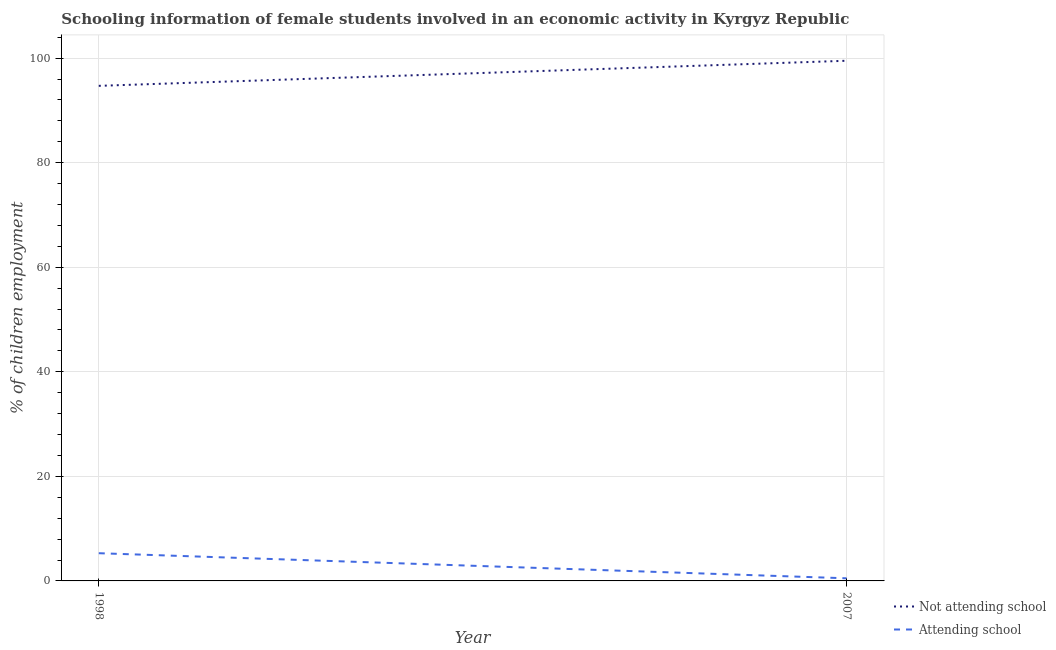Is the number of lines equal to the number of legend labels?
Make the answer very short. Yes. What is the percentage of employed females who are not attending school in 2007?
Provide a succinct answer. 99.5. Across all years, what is the maximum percentage of employed females who are attending school?
Provide a short and direct response. 5.3. Across all years, what is the minimum percentage of employed females who are attending school?
Your answer should be compact. 0.5. What is the total percentage of employed females who are not attending school in the graph?
Ensure brevity in your answer.  194.2. What is the difference between the percentage of employed females who are attending school in 1998 and the percentage of employed females who are not attending school in 2007?
Ensure brevity in your answer.  -94.2. What is the average percentage of employed females who are not attending school per year?
Provide a short and direct response. 97.1. In the year 1998, what is the difference between the percentage of employed females who are attending school and percentage of employed females who are not attending school?
Offer a terse response. -89.4. What is the ratio of the percentage of employed females who are attending school in 1998 to that in 2007?
Give a very brief answer. 10.6. Is the percentage of employed females who are attending school in 1998 less than that in 2007?
Your response must be concise. No. Is the percentage of employed females who are attending school strictly less than the percentage of employed females who are not attending school over the years?
Your response must be concise. Yes. What is the difference between two consecutive major ticks on the Y-axis?
Provide a short and direct response. 20. Does the graph contain any zero values?
Your response must be concise. No. Where does the legend appear in the graph?
Offer a terse response. Bottom right. How many legend labels are there?
Make the answer very short. 2. How are the legend labels stacked?
Ensure brevity in your answer.  Vertical. What is the title of the graph?
Make the answer very short. Schooling information of female students involved in an economic activity in Kyrgyz Republic. Does "Chemicals" appear as one of the legend labels in the graph?
Offer a very short reply. No. What is the label or title of the X-axis?
Your answer should be compact. Year. What is the label or title of the Y-axis?
Your response must be concise. % of children employment. What is the % of children employment of Not attending school in 1998?
Make the answer very short. 94.7. What is the % of children employment of Attending school in 1998?
Your response must be concise. 5.3. What is the % of children employment in Not attending school in 2007?
Your answer should be very brief. 99.5. What is the % of children employment of Attending school in 2007?
Your answer should be compact. 0.5. Across all years, what is the maximum % of children employment of Not attending school?
Your answer should be very brief. 99.5. Across all years, what is the maximum % of children employment in Attending school?
Provide a succinct answer. 5.3. Across all years, what is the minimum % of children employment of Not attending school?
Offer a terse response. 94.7. Across all years, what is the minimum % of children employment of Attending school?
Keep it short and to the point. 0.5. What is the total % of children employment of Not attending school in the graph?
Give a very brief answer. 194.2. What is the difference between the % of children employment in Not attending school in 1998 and the % of children employment in Attending school in 2007?
Your answer should be compact. 94.2. What is the average % of children employment of Not attending school per year?
Ensure brevity in your answer.  97.1. In the year 1998, what is the difference between the % of children employment in Not attending school and % of children employment in Attending school?
Ensure brevity in your answer.  89.4. In the year 2007, what is the difference between the % of children employment of Not attending school and % of children employment of Attending school?
Your answer should be compact. 99. What is the ratio of the % of children employment of Not attending school in 1998 to that in 2007?
Give a very brief answer. 0.95. What is the difference between the highest and the second highest % of children employment in Not attending school?
Ensure brevity in your answer.  4.8. What is the difference between the highest and the second highest % of children employment of Attending school?
Offer a terse response. 4.8. What is the difference between the highest and the lowest % of children employment of Not attending school?
Offer a very short reply. 4.8. What is the difference between the highest and the lowest % of children employment of Attending school?
Make the answer very short. 4.8. 